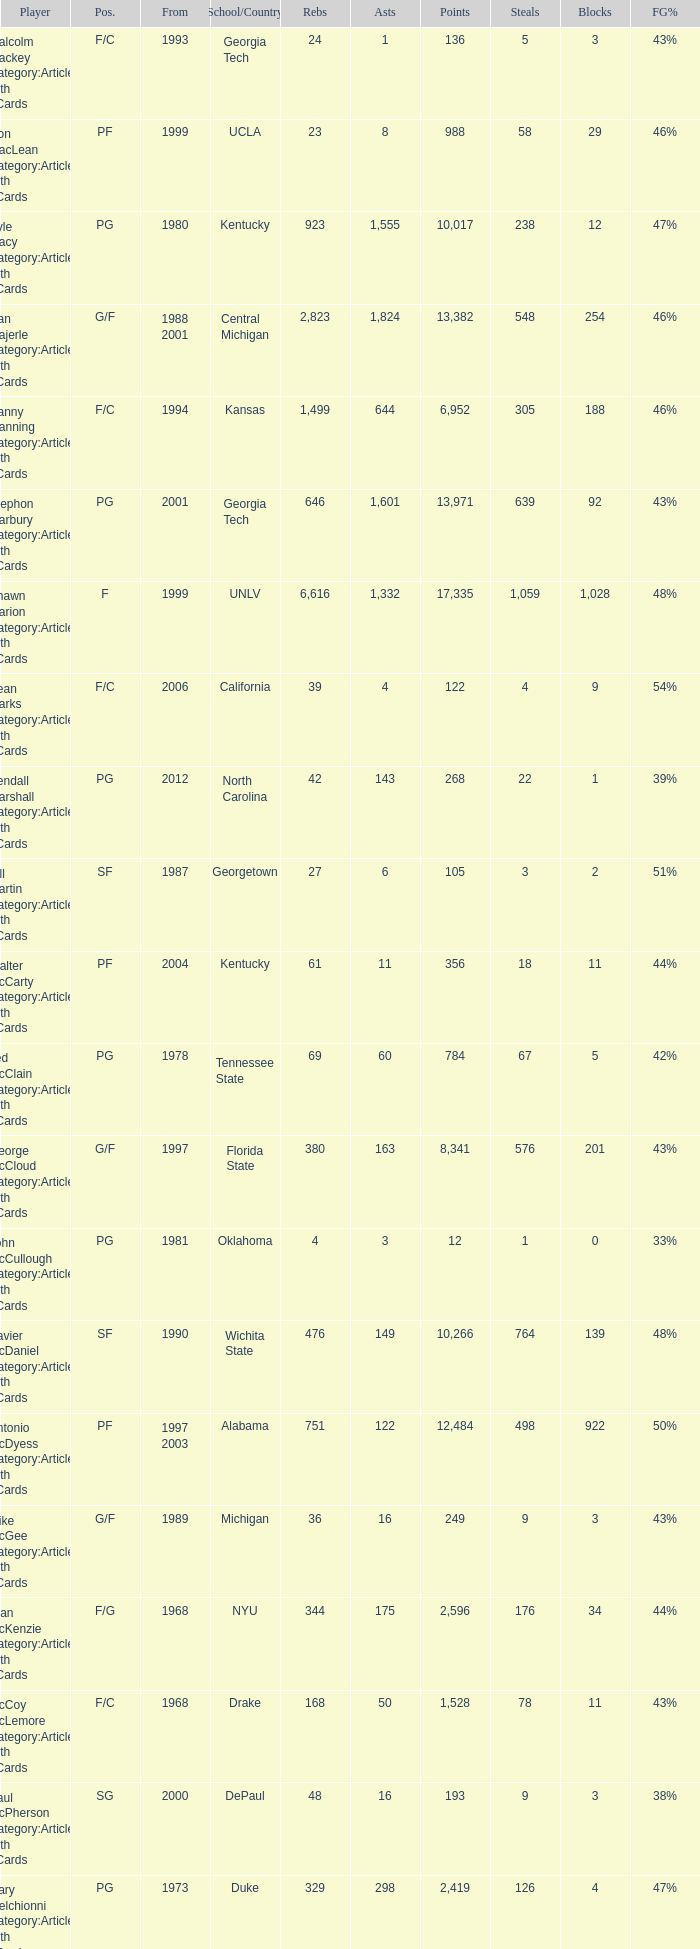Who has the high assists in 2000? 16.0. 